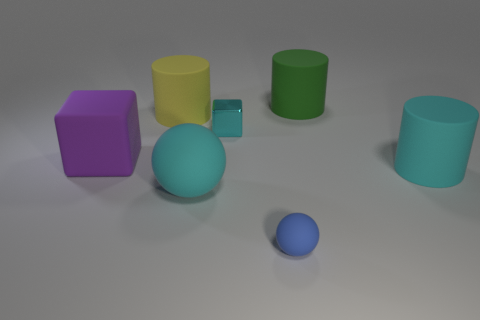What size is the metallic block that is the same color as the big matte sphere?
Give a very brief answer. Small. There is a big ball; does it have the same color as the tiny thing that is behind the small blue matte ball?
Offer a terse response. Yes. Does the tiny metal object have the same color as the big rubber sphere?
Offer a very short reply. Yes. How many other objects are there of the same color as the small block?
Provide a short and direct response. 2. How many big yellow cylinders are there?
Keep it short and to the point. 1. Are there fewer matte cylinders left of the cyan matte cylinder than cyan cylinders?
Offer a very short reply. No. Is the material of the large cyan object that is to the left of the metallic thing the same as the tiny blue thing?
Give a very brief answer. Yes. The big cyan matte thing left of the small object in front of the cyan thing to the right of the small ball is what shape?
Provide a short and direct response. Sphere. Is there a purple rubber block that has the same size as the yellow matte thing?
Provide a succinct answer. Yes. The shiny cube has what size?
Provide a short and direct response. Small. 